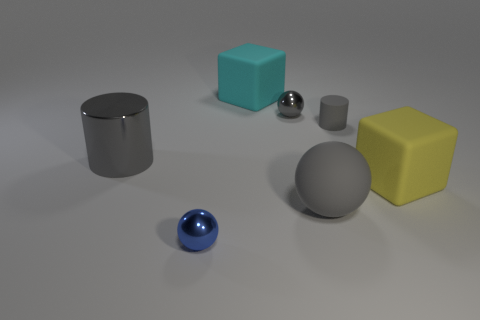What number of gray cylinders are on the left side of the metal sphere that is to the right of the small metallic ball that is on the left side of the big cyan rubber cube?
Keep it short and to the point. 1. There is another rubber thing that is the same shape as the large yellow matte thing; what color is it?
Make the answer very short. Cyan. The gray object that is in front of the large block in front of the tiny gray thing that is behind the small cylinder is what shape?
Your answer should be very brief. Sphere. There is a rubber thing that is behind the yellow rubber object and in front of the cyan rubber thing; what is its size?
Make the answer very short. Small. Is the number of red rubber objects less than the number of metallic objects?
Make the answer very short. Yes. What size is the gray ball behind the big gray metallic thing?
Provide a short and direct response. Small. There is a thing that is in front of the small gray cylinder and behind the big yellow thing; what is its shape?
Offer a very short reply. Cylinder. There is another gray thing that is the same shape as the large metallic thing; what is its size?
Your answer should be very brief. Small. How many tiny red spheres have the same material as the big cyan thing?
Provide a succinct answer. 0. There is a small matte cylinder; is it the same color as the shiny object to the right of the tiny blue metal object?
Ensure brevity in your answer.  Yes. 